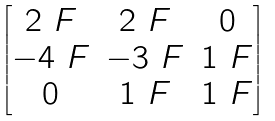Convert formula to latex. <formula><loc_0><loc_0><loc_500><loc_500>\begin{bmatrix} 2 _ { \ } F & 2 _ { \ } F & 0 \\ - 4 _ { \ } F & - 3 _ { \ } F & 1 _ { \ } F \\ 0 & 1 _ { \ } F & 1 _ { \ } F \end{bmatrix}</formula> 